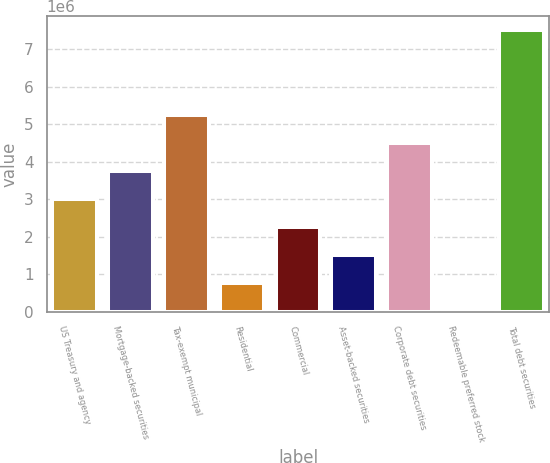Convert chart. <chart><loc_0><loc_0><loc_500><loc_500><bar_chart><fcel>US Treasury and agency<fcel>Mortgage-backed securities<fcel>Tax-exempt municipal<fcel>Residential<fcel>Commercial<fcel>Asset-backed securities<fcel>Corporate debt securities<fcel>Redeemable preferred stock<fcel>Total debt securities<nl><fcel>3.00684e+06<fcel>3.75522e+06<fcel>5.252e+06<fcel>761685<fcel>2.25846e+06<fcel>1.51007e+06<fcel>4.50361e+06<fcel>13300<fcel>7.49715e+06<nl></chart> 